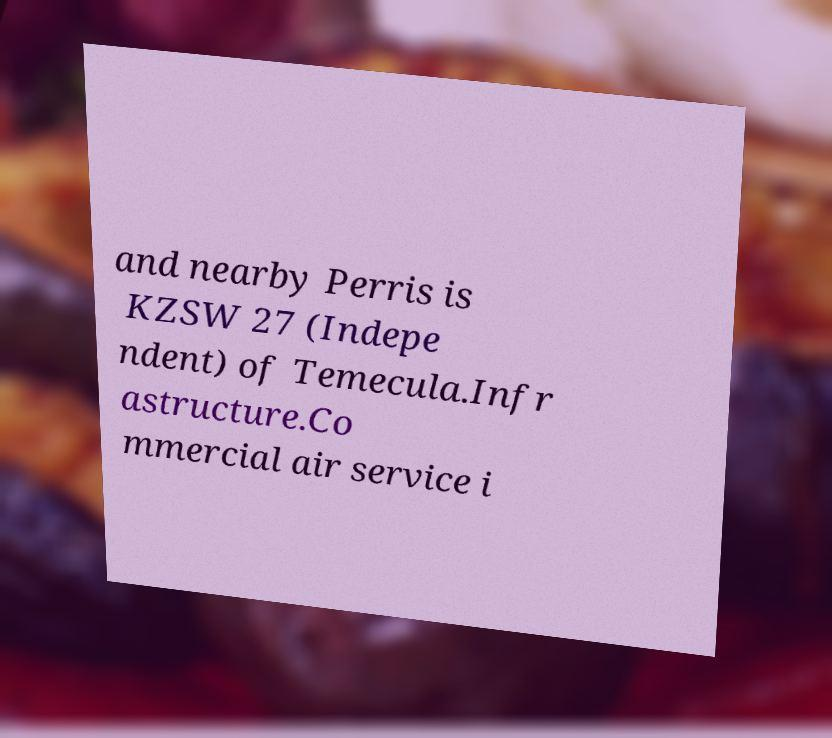Can you read and provide the text displayed in the image?This photo seems to have some interesting text. Can you extract and type it out for me? and nearby Perris is KZSW 27 (Indepe ndent) of Temecula.Infr astructure.Co mmercial air service i 